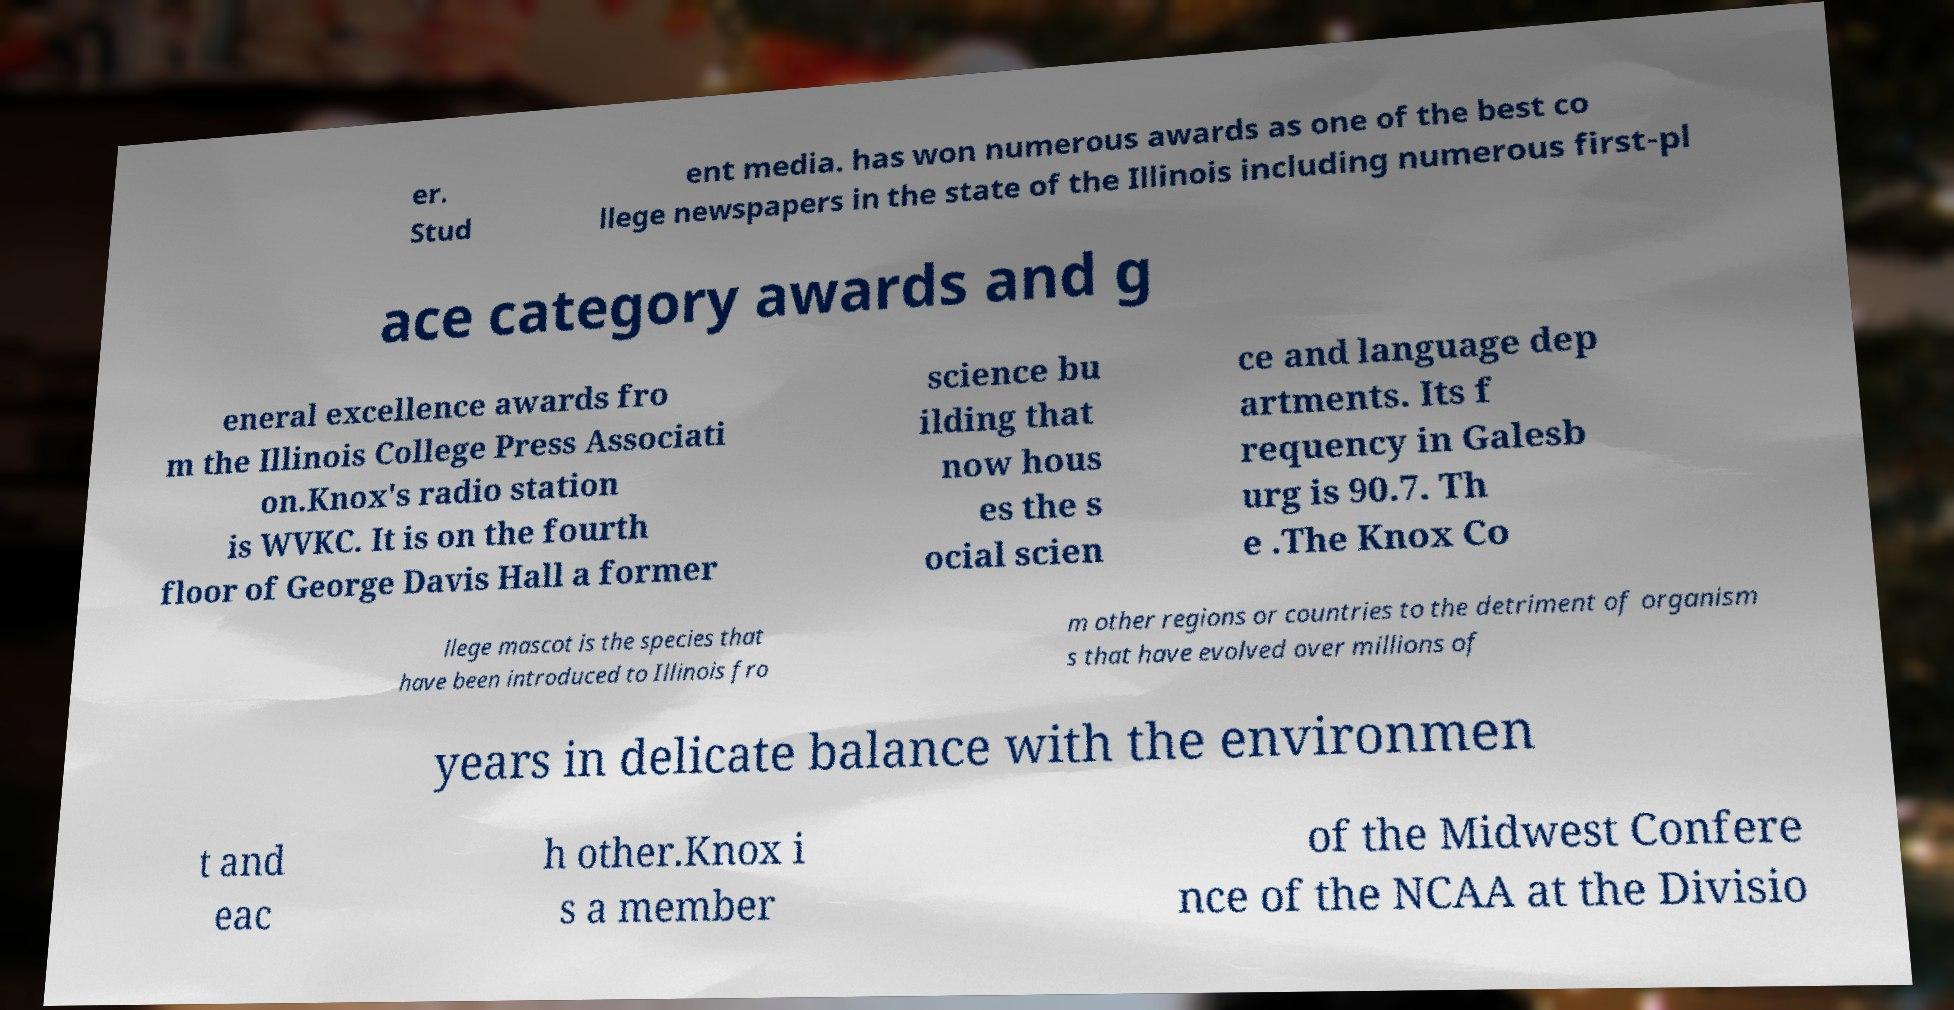Can you accurately transcribe the text from the provided image for me? er. Stud ent media. has won numerous awards as one of the best co llege newspapers in the state of the Illinois including numerous first-pl ace category awards and g eneral excellence awards fro m the Illinois College Press Associati on.Knox's radio station is WVKC. It is on the fourth floor of George Davis Hall a former science bu ilding that now hous es the s ocial scien ce and language dep artments. Its f requency in Galesb urg is 90.7. Th e .The Knox Co llege mascot is the species that have been introduced to Illinois fro m other regions or countries to the detriment of organism s that have evolved over millions of years in delicate balance with the environmen t and eac h other.Knox i s a member of the Midwest Confere nce of the NCAA at the Divisio 